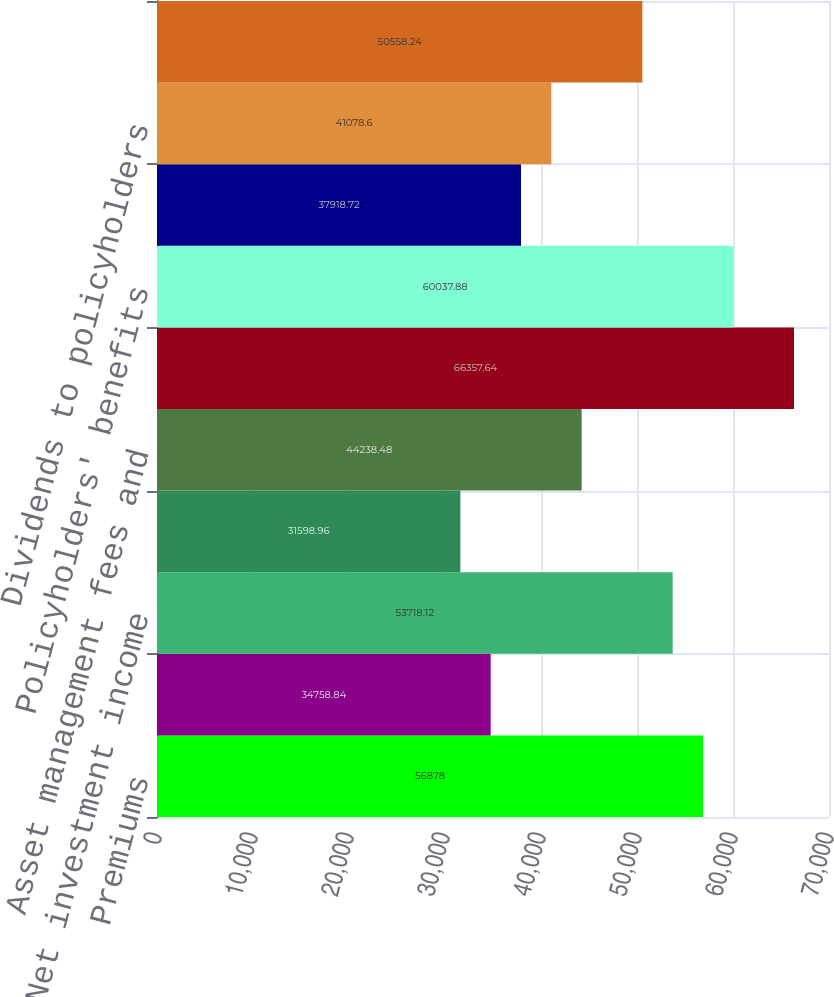<chart> <loc_0><loc_0><loc_500><loc_500><bar_chart><fcel>Premiums<fcel>Policy charges and fee income<fcel>Net investment income<fcel>Realized investment gains net<fcel>Asset management fees and<fcel>Total revenues<fcel>Policyholders' benefits<fcel>Interest credited to<fcel>Dividends to policyholders<fcel>General and administrative<nl><fcel>56878<fcel>34758.8<fcel>53718.1<fcel>31599<fcel>44238.5<fcel>66357.6<fcel>60037.9<fcel>37918.7<fcel>41078.6<fcel>50558.2<nl></chart> 